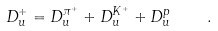Convert formula to latex. <formula><loc_0><loc_0><loc_500><loc_500>D _ { u } ^ { + } = D _ { u } ^ { \pi ^ { + } } + D _ { u } ^ { K ^ { + } } + D _ { u } ^ { p } \quad .</formula> 